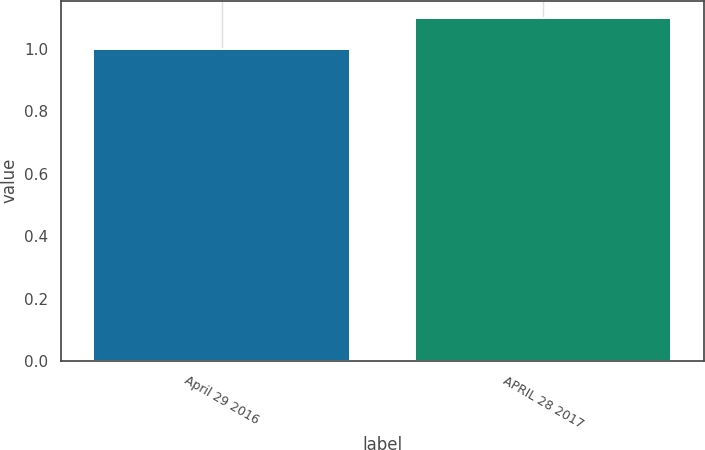Convert chart to OTSL. <chart><loc_0><loc_0><loc_500><loc_500><bar_chart><fcel>April 29 2016<fcel>APRIL 28 2017<nl><fcel>1<fcel>1.1<nl></chart> 